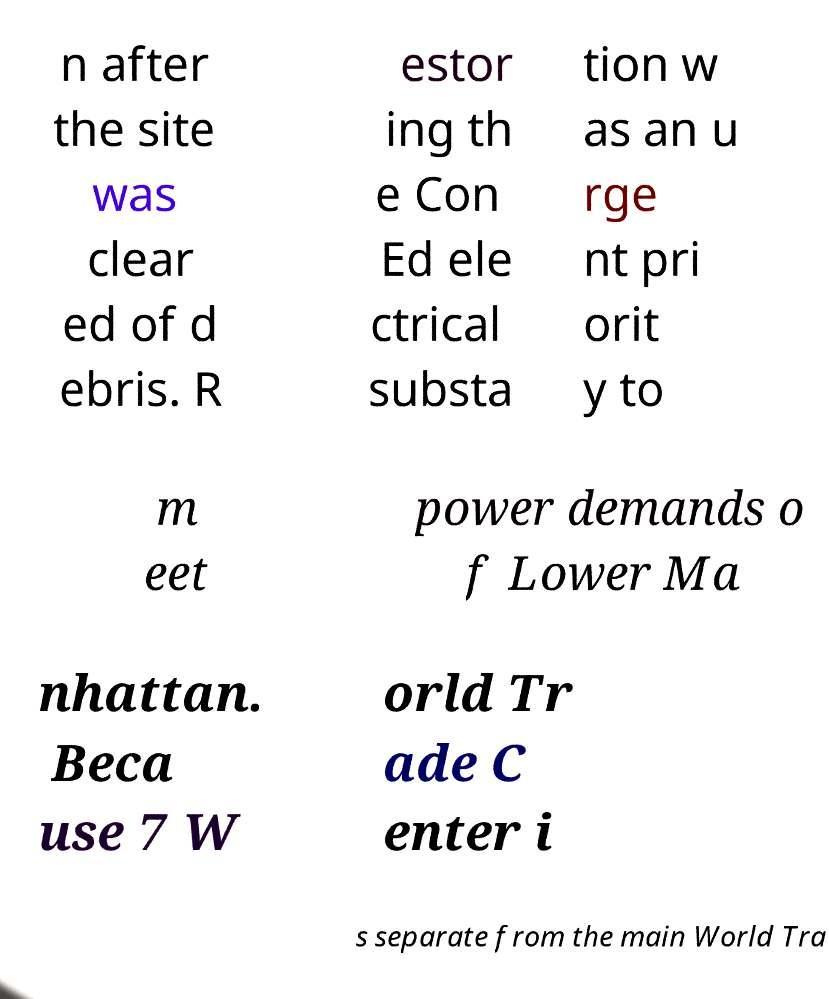For documentation purposes, I need the text within this image transcribed. Could you provide that? n after the site was clear ed of d ebris. R estor ing th e Con Ed ele ctrical substa tion w as an u rge nt pri orit y to m eet power demands o f Lower Ma nhattan. Beca use 7 W orld Tr ade C enter i s separate from the main World Tra 